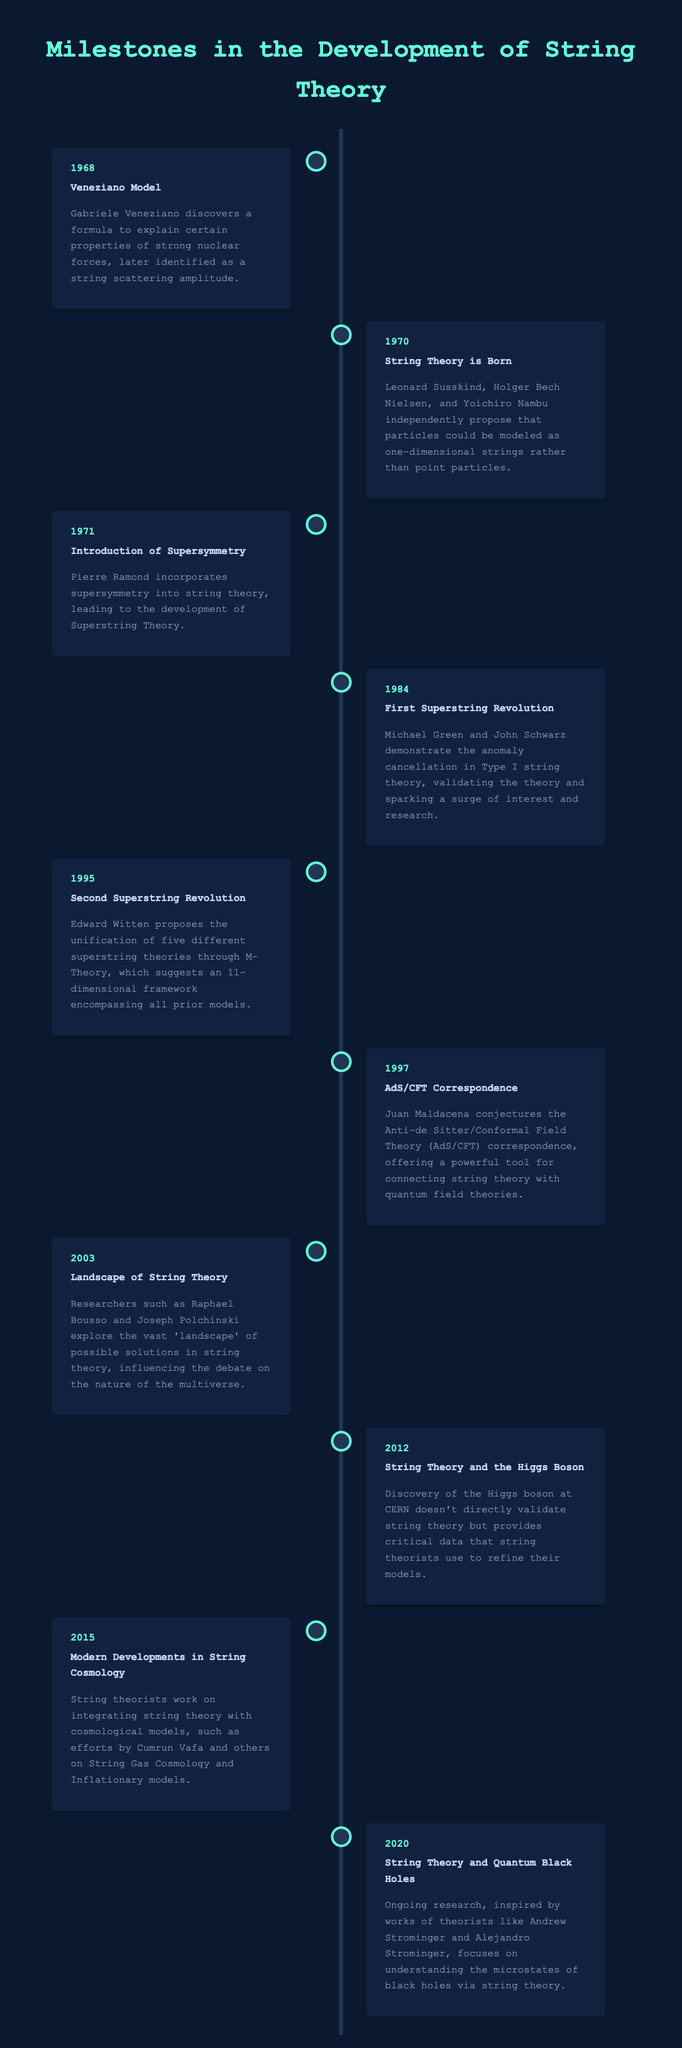What year was the Veneziano Model discovered? The Veneziano Model was discovered in 1968, as indicated in the timeline.
Answer: 1968 Who proposed the unification of superstring theories? Edward Witten proposed the unification of superstring theories with M-Theory in 1995.
Answer: Edward Witten What significant development in string theory occurred in 1984? In 1984, the first superstring revolution took place, led by Michael Green and John Schwarz demonstrating anomaly cancellation.
Answer: First Superstring Revolution What year did the AdS/CFT correspondence conjecture arise? The AdS/CFT correspondence was conjectured in 1997 by Juan Maldacena.
Answer: 1997 How many different superstring theories were unified through M-Theory? Five different superstring theories were unified through M-Theory.
Answer: Five Which physicist is associated with the introduction of supersymmetry into string theory? Pierre Ramond is associated with introducing supersymmetry into string theory in 1971.
Answer: Pierre Ramond What crucial particle discovery at CERN in 2012 is mentioned in relation to string theory? The discovery of the Higgs boson at CERN is mentioned.
Answer: Higgs boson What concept related to string cosmology was discussed in 2015? In 2015, the integration of string theory with cosmological models was discussed.
Answer: String Cosmology Identify a major development in string theory from the year 2003. The exploration of the landscape of string theory solutions was a major development in 2003.
Answer: Landscape of String Theory What did the timeline indicate about string theory and quantum black holes in 2020? The timeline indicated that ongoing research focused on understanding the microstates of black holes via string theory in 2020.
Answer: String Theory and Quantum Black Holes 